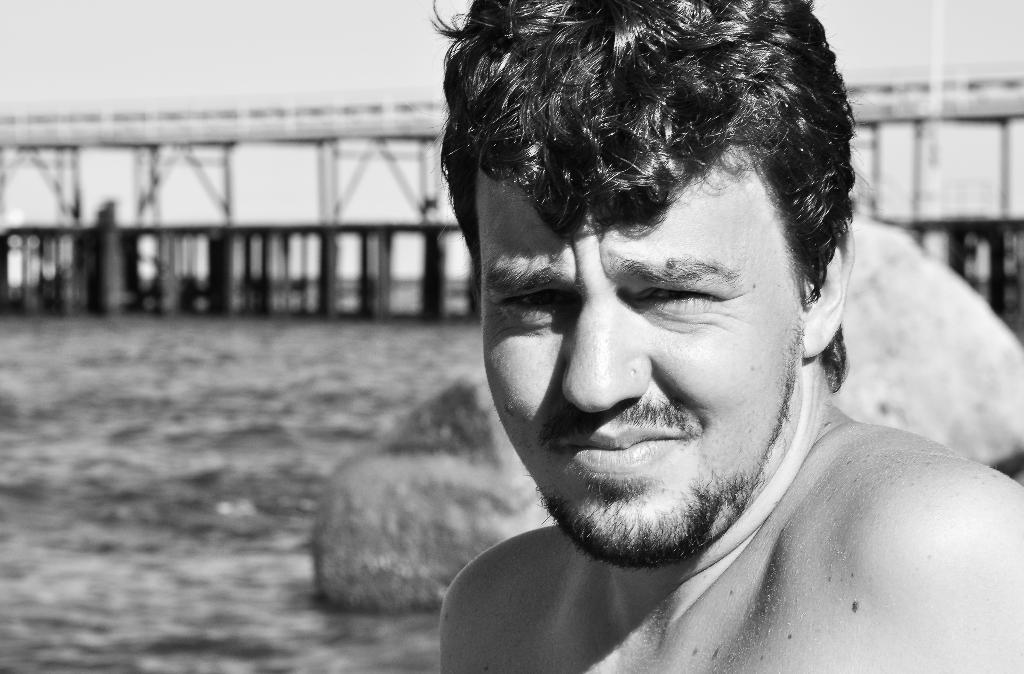Who is the main subject in the picture? There is a man in the middle of the picture. What natural feature can be seen on the left side of the picture? There is a river on the left side of the picture. Can you describe the background of the image? The background of the image is blurred. What month is the man's mind in the image? There is no indication of the month or the man's mental state in the image. 